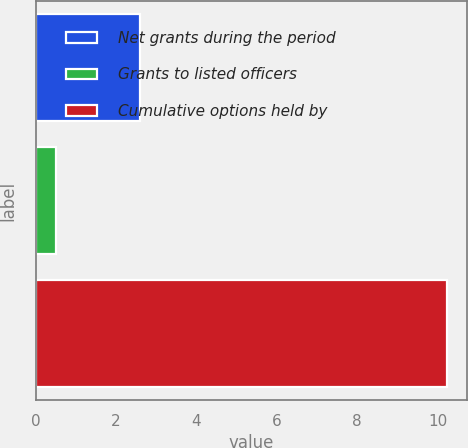Convert chart to OTSL. <chart><loc_0><loc_0><loc_500><loc_500><bar_chart><fcel>Net grants during the period<fcel>Grants to listed officers<fcel>Cumulative options held by<nl><fcel>2.6<fcel>0.5<fcel>10.23<nl></chart> 